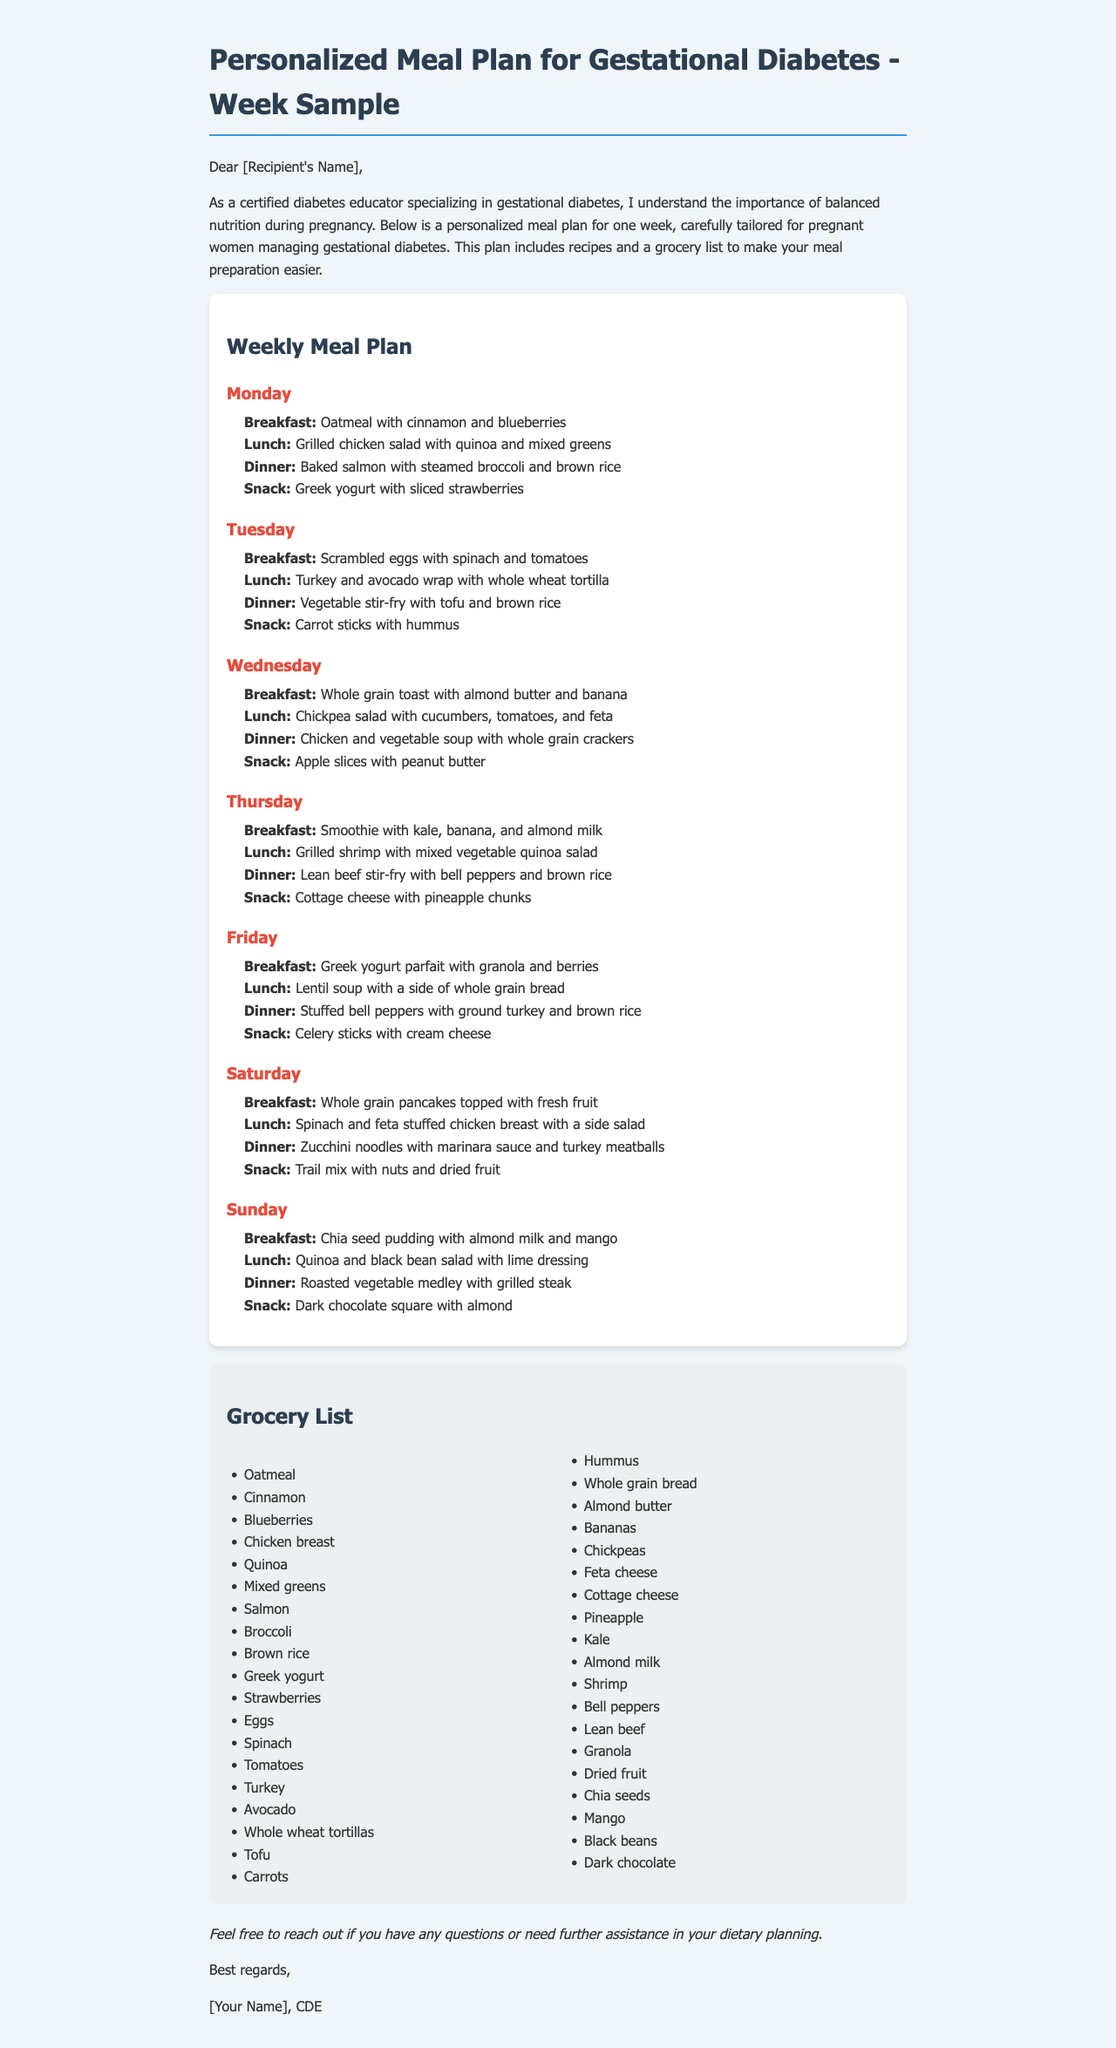What is the title of the meal plan document? The title appears at the beginning of the document and is "Personalized Meal Plan for Gestational Diabetes - Week Sample."
Answer: Personalized Meal Plan for Gestational Diabetes - Week Sample How many days are included in the meal plan? The meal plan is structured to cover each day of the week, which totals to seven days.
Answer: Seven days What is the first breakfast option listed? The first breakfast option under Monday is specified as "Oatmeal with cinnamon and blueberries."
Answer: Oatmeal with cinnamon and blueberries Which snack includes fruit on Friday? The snack mentioned for Friday that includes fruit is "Celery sticks with cream cheese."
Answer: Celery sticks with cream cheese What type of protein is included in the dinner on Tuesday? Looking at the Tuesday dinner, the protein included is "tofu."
Answer: Tofu What type of milk is used in the Thursday smoothie? The Thursday smoothie recipe lists "almond milk" as one of its ingredients.
Answer: Almond milk What is the total number of listed grocery items? The grocery list contains multiple ingredients, which when counted amounts to thirty-three items total.
Answer: Thirty-three items What snack is suggested for Sunday? The specified snack for Sunday is "Dark chocolate square with almond."
Answer: Dark chocolate square with almond What is highlighted about the purpose of the meal plan? The document states that it is a personalized meal plan specifically designed for "pregnant women managing gestational diabetes."
Answer: Pregnant women managing gestational diabetes 